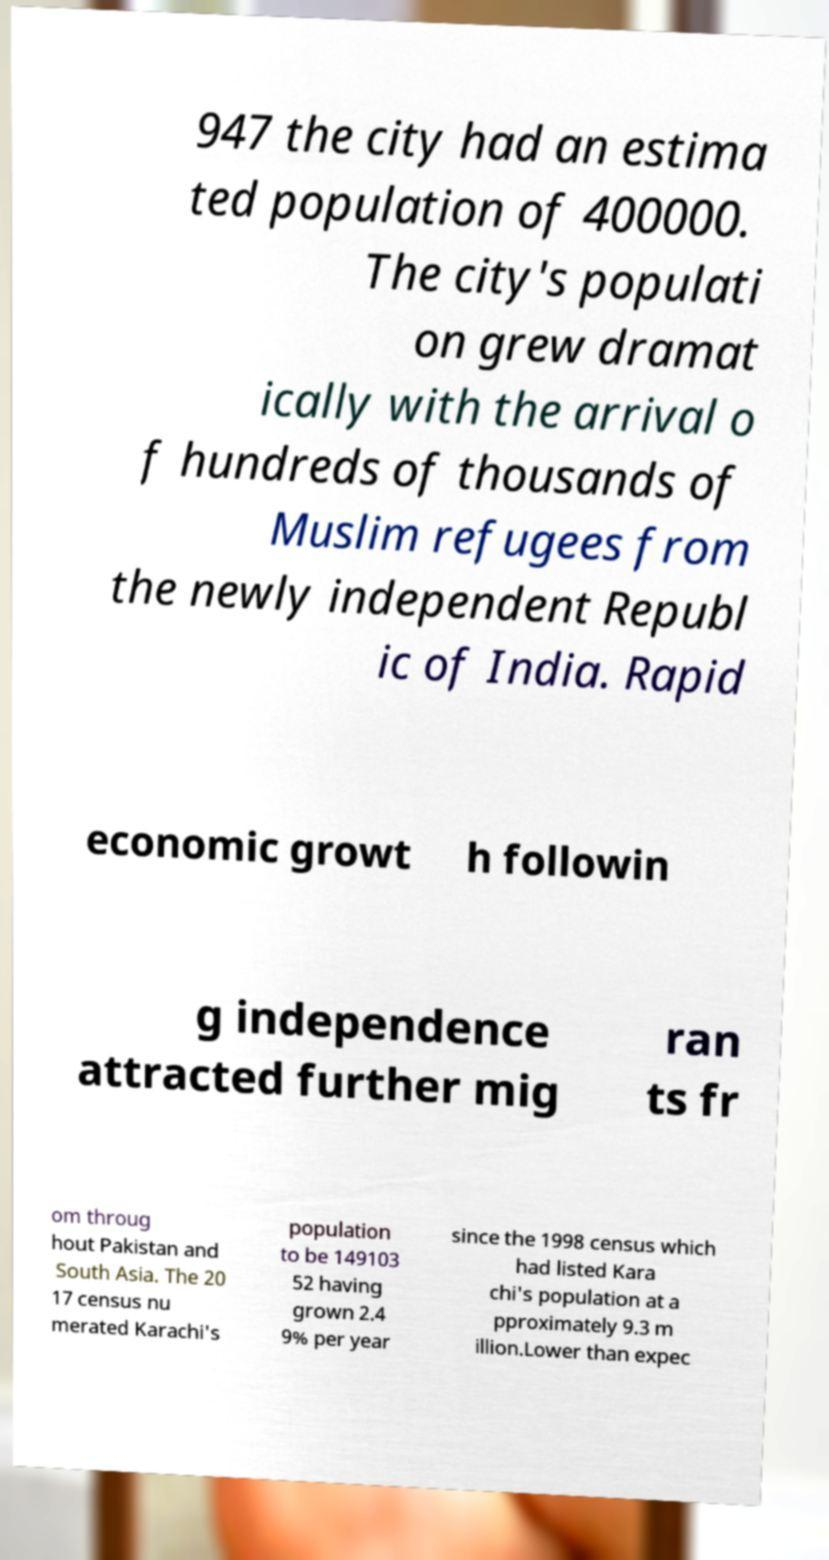What messages or text are displayed in this image? I need them in a readable, typed format. 947 the city had an estima ted population of 400000. The city's populati on grew dramat ically with the arrival o f hundreds of thousands of Muslim refugees from the newly independent Republ ic of India. Rapid economic growt h followin g independence attracted further mig ran ts fr om throug hout Pakistan and South Asia. The 20 17 census nu merated Karachi's population to be 149103 52 having grown 2.4 9% per year since the 1998 census which had listed Kara chi's population at a pproximately 9.3 m illion.Lower than expec 